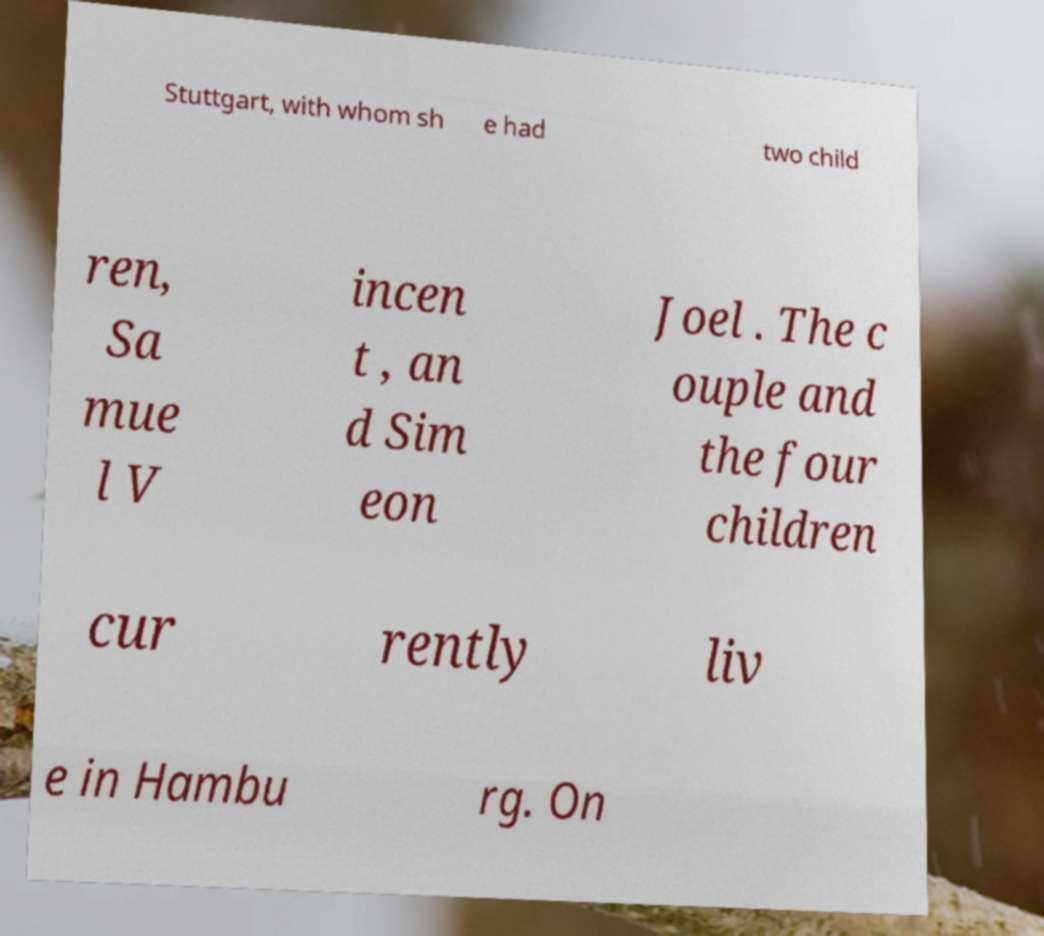What messages or text are displayed in this image? I need them in a readable, typed format. Stuttgart, with whom sh e had two child ren, Sa mue l V incen t , an d Sim eon Joel . The c ouple and the four children cur rently liv e in Hambu rg. On 